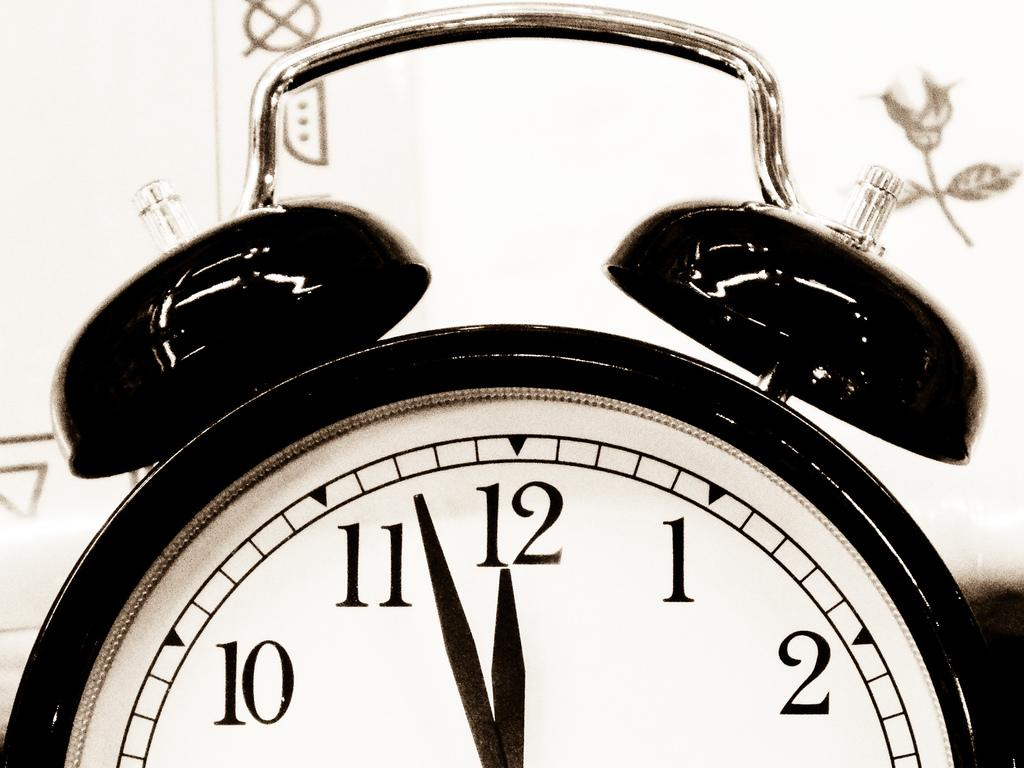<image>
Relay a brief, clear account of the picture shown. A black with a white face alarm clock is showing a few minutes before 12. 